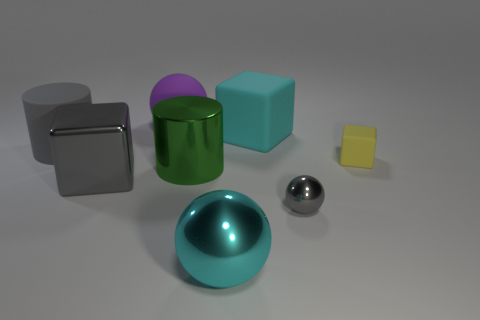There is a block that is the same color as the tiny shiny ball; what is its size?
Your answer should be very brief. Large. What material is the cylinder left of the purple object?
Give a very brief answer. Rubber. What number of tiny things are red blocks or matte balls?
Your answer should be very brief. 0. There is a cylinder on the right side of the gray rubber object; is its size the same as the small yellow block?
Provide a short and direct response. No. What number of other things are the same color as the metallic block?
Ensure brevity in your answer.  2. What is the small gray object made of?
Your answer should be compact. Metal. There is a thing that is both right of the large cyan metal object and behind the tiny yellow matte cube; what material is it made of?
Ensure brevity in your answer.  Rubber. What number of objects are either matte objects that are behind the large gray cylinder or cyan matte things?
Your answer should be very brief. 2. Is the metallic block the same color as the matte cylinder?
Make the answer very short. Yes. Are there any purple matte cubes of the same size as the yellow block?
Offer a very short reply. No. 